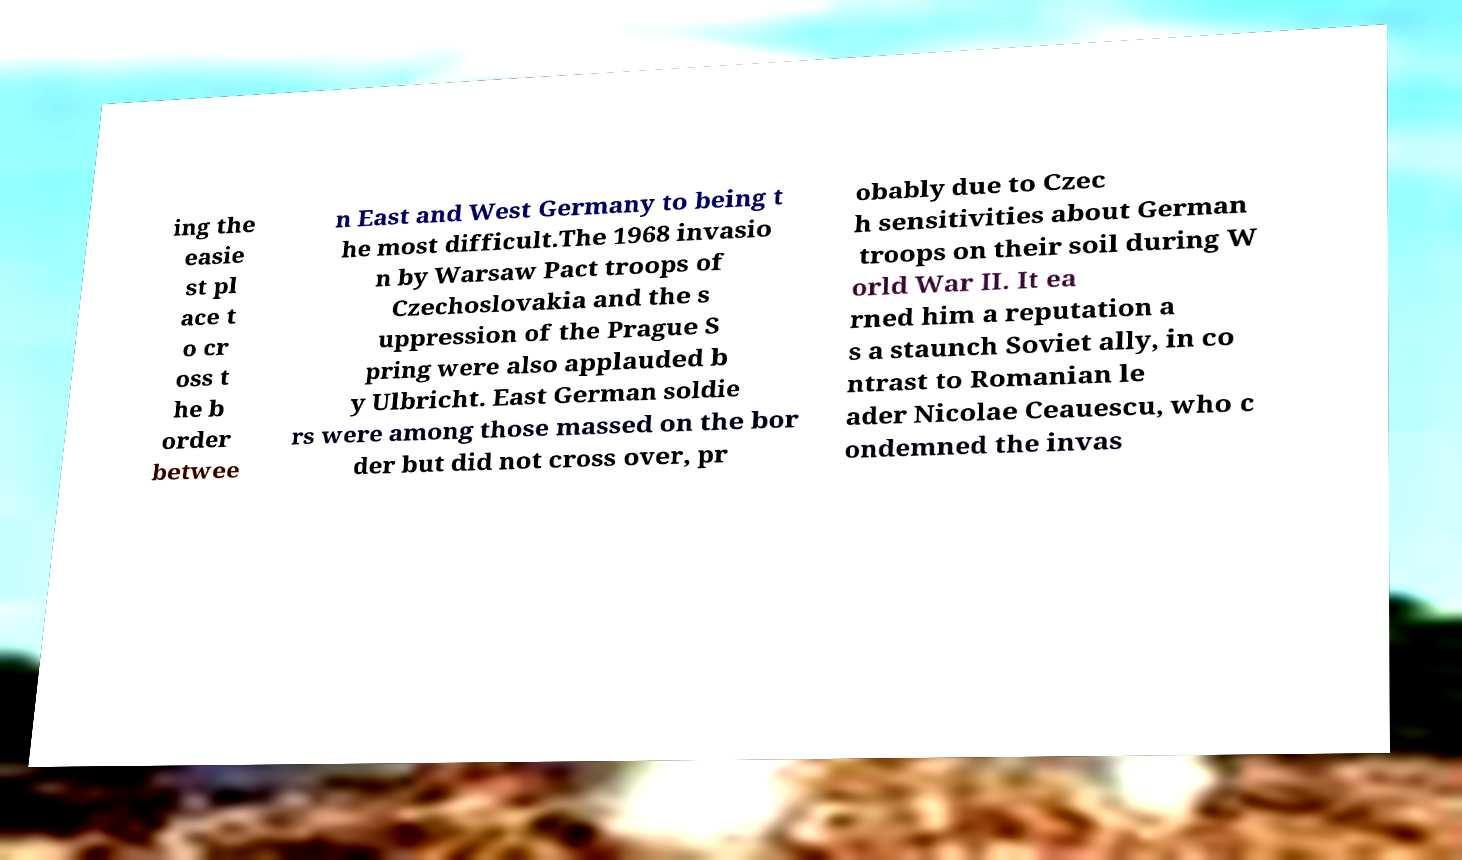Please identify and transcribe the text found in this image. ing the easie st pl ace t o cr oss t he b order betwee n East and West Germany to being t he most difficult.The 1968 invasio n by Warsaw Pact troops of Czechoslovakia and the s uppression of the Prague S pring were also applauded b y Ulbricht. East German soldie rs were among those massed on the bor der but did not cross over, pr obably due to Czec h sensitivities about German troops on their soil during W orld War II. It ea rned him a reputation a s a staunch Soviet ally, in co ntrast to Romanian le ader Nicolae Ceauescu, who c ondemned the invas 